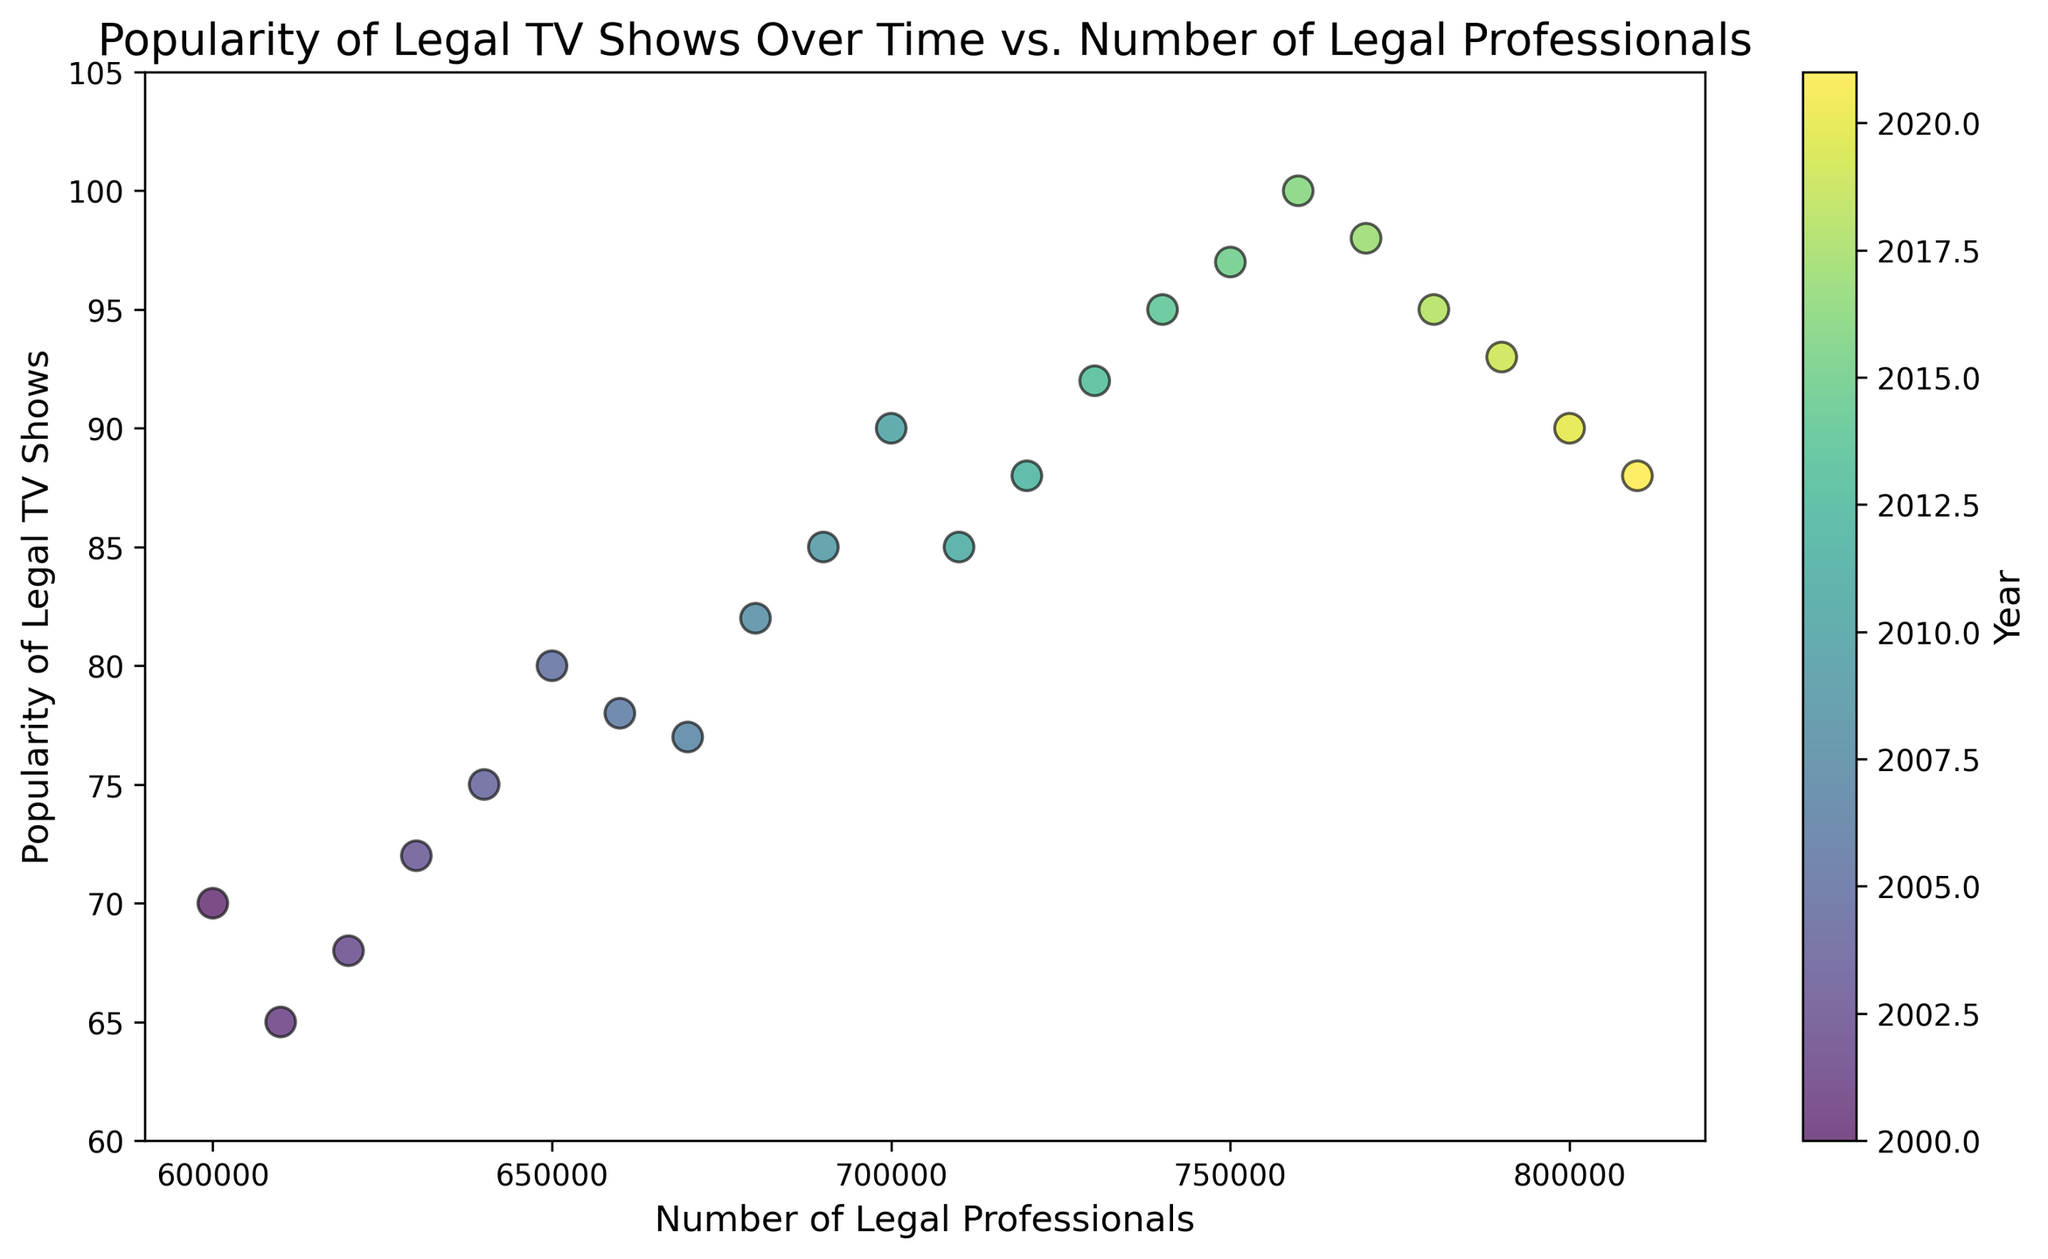什么年份法律题材电视节目最受欢迎？ 按照颜色刻度条，可以看到2016年是最受欢迎的年份，法庭剧受欢迎度为100
Answer: 2016 法庭剧受欢迎度在80以上的年份有哪些？ 根据颜色和数据点位置，可以看到2008，2009，2010，2012，2013，2014，2015，2016和2017年的受欢迎度都在80以上
Answer: 2008，2009，2010，2012，2013，2014，2015，2016，2017 在法庭剧受欢迎度高峰期（2016年），法律从业人员的数量是多少？ 参照2016年数据点的位置和颜色，可以看到法律从业人员数量是760000
Answer: 760000 2018年法庭剧的受欢迎度比2010年高还是低？ 通过颜色和数据点的位置对比2018年的93（绿色）和2010年的90（黄色），可以得出2018年比2010年高一些
Answer: 高 在图表中法庭剧受欢迎度增长最快的是哪两个年份？ 比较所有年份的受欢迎度变化，2004年到2005年受欢迎度从75到80是最大的增长，同时2015年到2016年从97到100也很显著
Answer: 2004-2005，2015-2016 法庭剧受欢迎度在下降期间出现过什么趋势吗？ 仔细观察数据点的颜色和位置，我们可以看到自2016年以来，受欢迎度总体趋向下降，分别是2016年的100，2017年的98，2018年的95，2019年的93，到2021年的88
Answer: 受欢迎度整体下降 哪个年份法律从业人员的数量首次达到70万？ 根据图表和颜色来看，2010年是法律从业人员首次达到70万人
Answer: 2010 比较2006年和2009年法庭剧受欢迎度变化有多大？ 2006年受欢迎度为78，2009年为85，变化为85 - 78 = 7
Answer: 7 随着时间推移，法律从业人员和法庭剧受欢迎度之间是否有明显的关系？ 整体来看，法律从业人员数量增加的同时，法庭剧受欢迎度大致也是上升的，尤其是2000年到2016年，但在之后受欢迎度略有下降。这表明两者之间存在一定的正相关性
Answer: 是 2001年到2003年法庭剧受欢迎度有何变化？ 根据颜色和数据点对比，2001年受欢迎度为65，2003年为72，因此变化为72 - 65 = 7
Answer: 7 